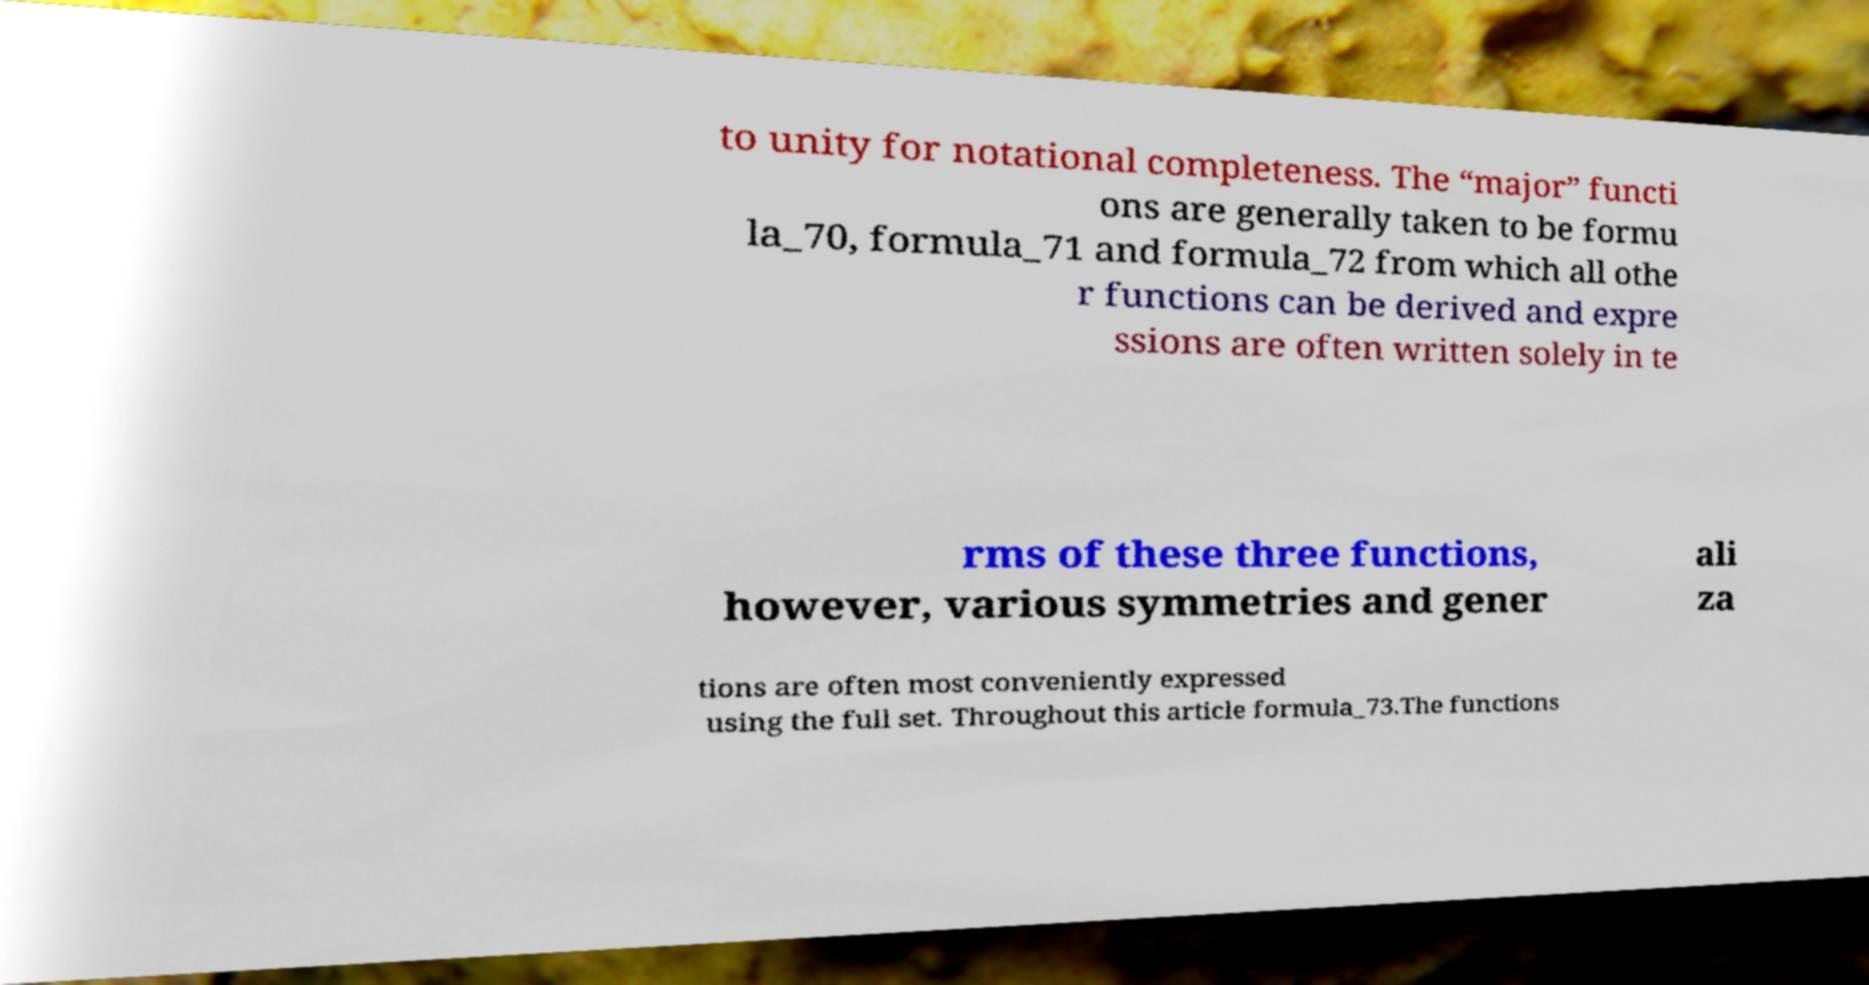Could you extract and type out the text from this image? to unity for notational completeness. The “major” functi ons are generally taken to be formu la_70, formula_71 and formula_72 from which all othe r functions can be derived and expre ssions are often written solely in te rms of these three functions, however, various symmetries and gener ali za tions are often most conveniently expressed using the full set. Throughout this article formula_73.The functions 